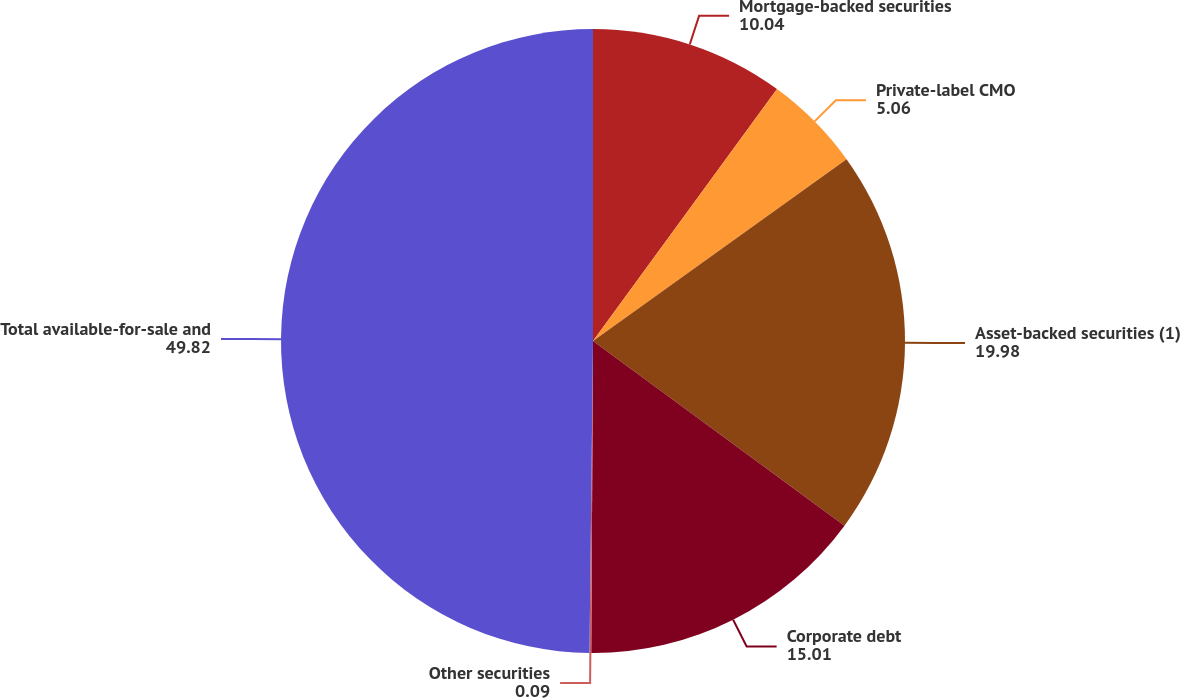Convert chart. <chart><loc_0><loc_0><loc_500><loc_500><pie_chart><fcel>Mortgage-backed securities<fcel>Private-label CMO<fcel>Asset-backed securities (1)<fcel>Corporate debt<fcel>Other securities<fcel>Total available-for-sale and<nl><fcel>10.04%<fcel>5.06%<fcel>19.98%<fcel>15.01%<fcel>0.09%<fcel>49.82%<nl></chart> 